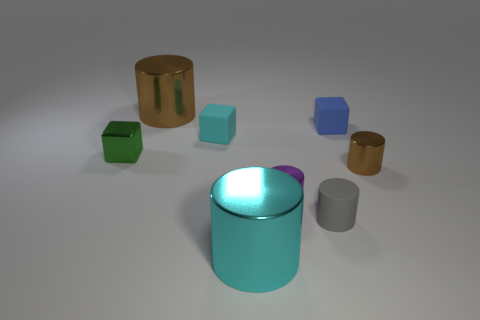Are there any blue cylinders made of the same material as the small cyan object?
Provide a succinct answer. No. There is a cylinder that is on the right side of the small rubber thing in front of the brown metallic thing that is on the right side of the large cyan thing; what is its color?
Give a very brief answer. Brown. There is a large cylinder to the left of the cyan metallic object; is its color the same as the metal thing that is to the right of the tiny purple shiny cylinder?
Offer a terse response. Yes. Is there any other thing that is the same color as the tiny metal cube?
Ensure brevity in your answer.  No. Is the number of tiny purple objects in front of the gray thing less than the number of purple metallic cylinders?
Give a very brief answer. Yes. What number of large brown cylinders are there?
Provide a short and direct response. 1. There is a gray object; does it have the same shape as the big object that is on the left side of the cyan shiny cylinder?
Provide a succinct answer. Yes. Is the number of green shiny cubes in front of the tiny green shiny block less than the number of gray cylinders that are to the left of the purple cylinder?
Offer a terse response. No. Does the gray matte thing have the same shape as the big cyan thing?
Offer a very short reply. Yes. How big is the cyan cylinder?
Your response must be concise. Large. 